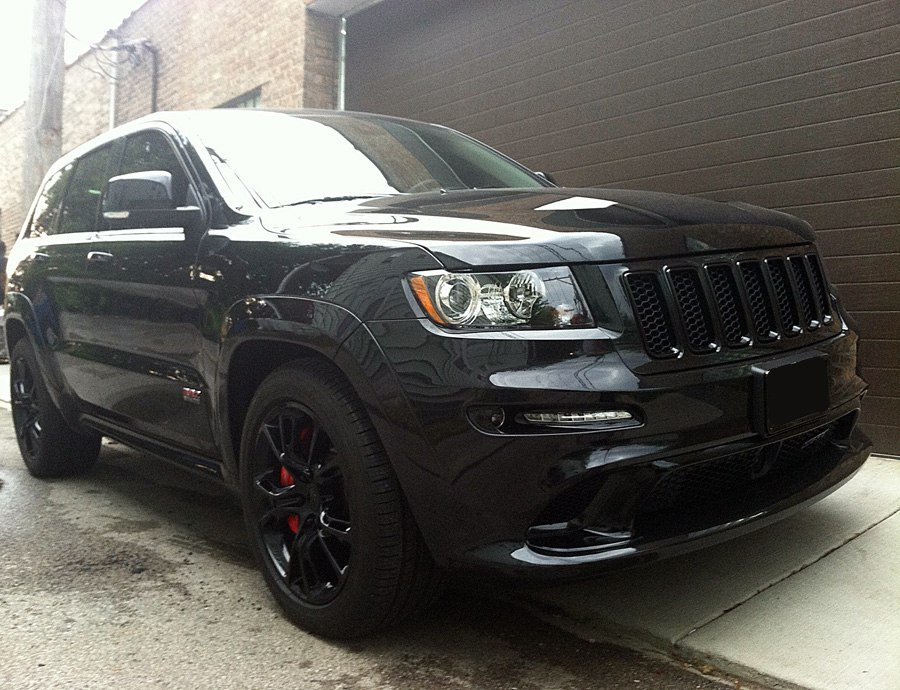Imagine this SUV in an action-packed movie scene. Describe the most thrilling sequence involving this vehicle. In an action-packed movie scene, this SUV roars to life under the cover of night, its glossy black exterior glistening under the city lights. The protagonist, with a determined look, floors the accelerator, and the vehicle launches forward with a deep growl. As it weaves through narrow alleyways, the low-profile tires grip the asphalt with precision, allowing sharp and agile maneuvers. The red brake calipers glow as they engage in rapid deceleration, narrowly avoiding collisions as the SUV navigates a fast-paced urban chase. With helicopters above and rival cars in pursuit, the SUV showcases its superior handling and impressive speed, ultimately executing a dramatic jump across a partially raised bridge, leaving the pursuers stunned and the protagonist with a victorious smile. How would the SUV handle in off-road conditions? Provide both the potential strengths and weaknesses. While this SUV is clearly designed for performance on paved roads, it does possess some characteristics that could be beneficial in off-road conditions. The powerful engine and robust construction suggest that it could handle rough terrain and inclines with relative ease. However, the low-profile tires and sporty suspension system are not ideal for off-road driving, as they may struggle with uneven surfaces and lack the necessary grip on loose or muddy paths. Additionally, the emphasis on speed and handling over ruggedness means that it might not be as durable under extreme off-road conditions compared to a dedicated off-road vehicle. In summary, while it can handle mild off-road situations, it is best suited for urban or highway driving. 